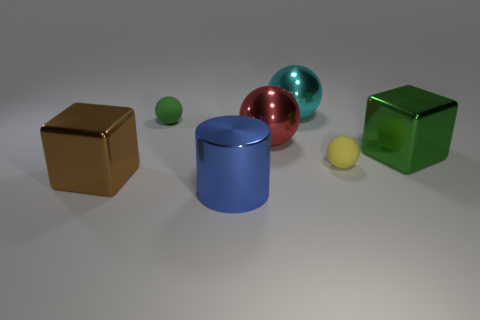Add 1 yellow rubber spheres. How many objects exist? 8 Subtract all purple spheres. Subtract all brown cylinders. How many spheres are left? 4 Subtract all cylinders. How many objects are left? 6 Subtract 0 blue balls. How many objects are left? 7 Subtract all tiny green metal cubes. Subtract all matte objects. How many objects are left? 5 Add 3 red shiny objects. How many red shiny objects are left? 4 Add 7 large blue metallic cylinders. How many large blue metallic cylinders exist? 8 